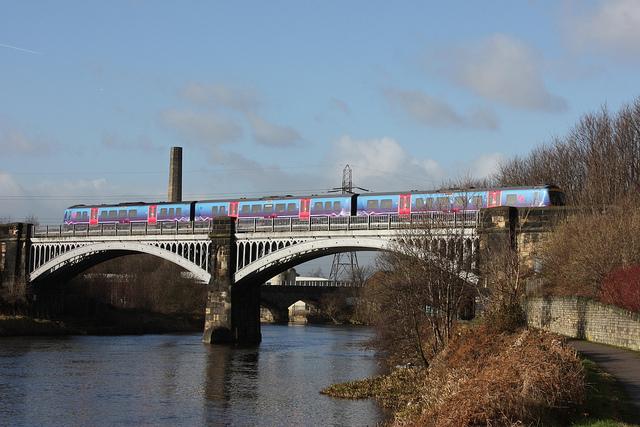What does the banner say?
Short answer required. Nothing. Is the train big or small?
Short answer required. Big. Is the train crossing the bridge?
Give a very brief answer. Yes. What color is the water?
Give a very brief answer. Blue. What is on the bridge?
Give a very brief answer. Train. Does that bridge look sturdy?
Write a very short answer. Yes. What is under the bridge?
Quick response, please. Water. 